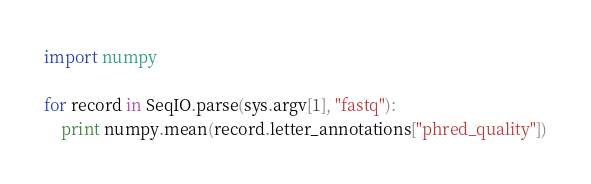<code> <loc_0><loc_0><loc_500><loc_500><_Python_>import numpy

for record in SeqIO.parse(sys.argv[1], "fastq"):
	print numpy.mean(record.letter_annotations["phred_quality"])


</code> 